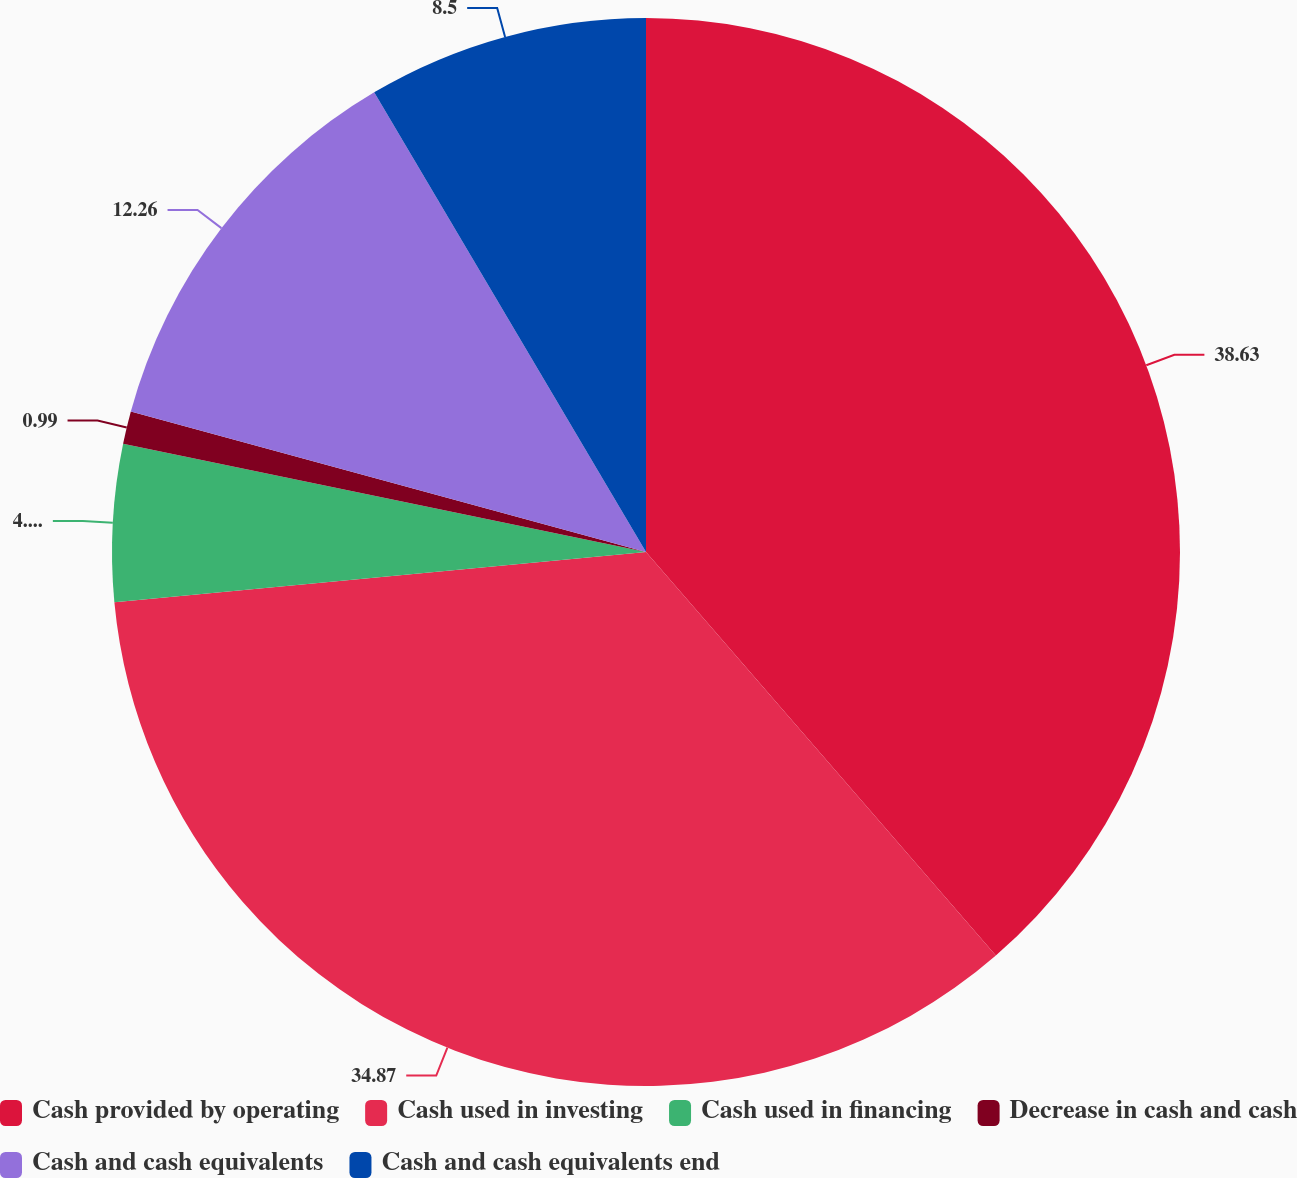<chart> <loc_0><loc_0><loc_500><loc_500><pie_chart><fcel>Cash provided by operating<fcel>Cash used in investing<fcel>Cash used in financing<fcel>Decrease in cash and cash<fcel>Cash and cash equivalents<fcel>Cash and cash equivalents end<nl><fcel>38.63%<fcel>34.87%<fcel>4.75%<fcel>0.99%<fcel>12.26%<fcel>8.5%<nl></chart> 